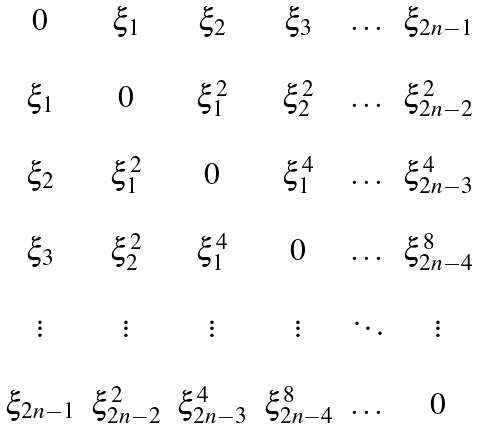Convert formula to latex. <formula><loc_0><loc_0><loc_500><loc_500>\begin{matrix} 0 & \xi _ { 1 } & \xi _ { 2 } & \xi _ { 3 } & \dots & \xi _ { 2 n - 1 } \\ \\ \xi _ { 1 } & 0 & \xi _ { 1 } ^ { 2 } & \xi _ { 2 } ^ { 2 } & \dots & \xi _ { 2 n - 2 } ^ { 2 } \\ \\ \xi _ { 2 } & \xi _ { 1 } ^ { 2 } & 0 & \xi _ { 1 } ^ { 4 } & \dots & \xi _ { 2 n - 3 } ^ { 4 } \\ \\ \xi _ { 3 } & \xi _ { 2 } ^ { 2 } & \xi _ { 1 } ^ { 4 } & 0 & \dots & \xi _ { 2 n - 4 } ^ { 8 } \\ \\ \vdots & \vdots & \vdots & \vdots & \ddots & \vdots \\ \\ \xi _ { 2 n - 1 } & \xi _ { 2 n - 2 } ^ { 2 } & \xi _ { 2 n - 3 } ^ { 4 } & \xi _ { 2 n - 4 } ^ { 8 } & \dots & 0 \\ \end{matrix}</formula> 